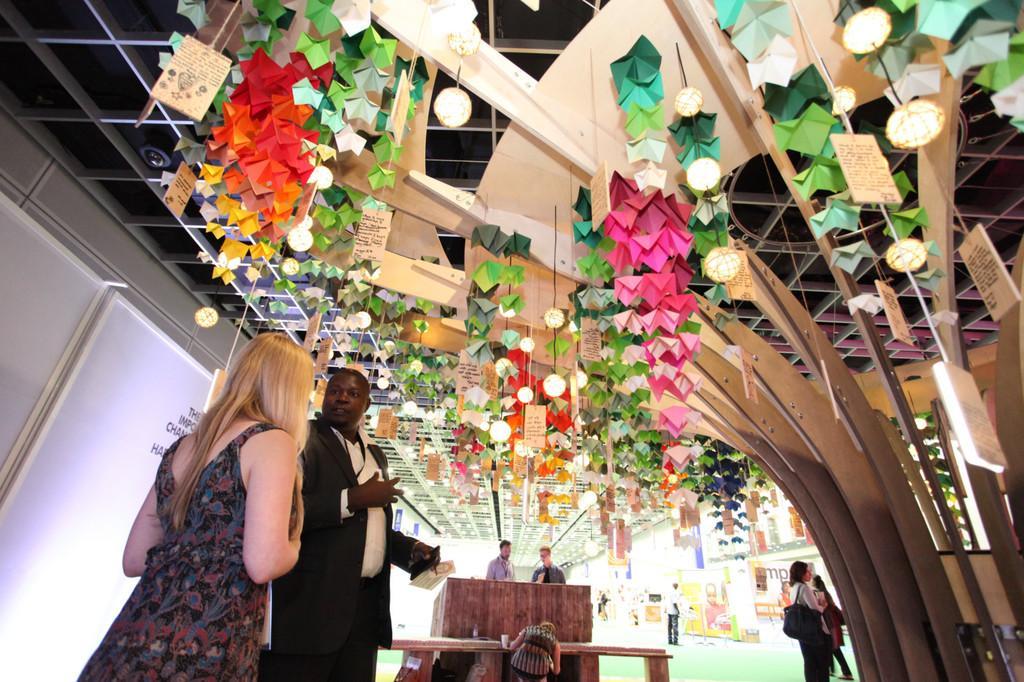How would you summarize this image in a sentence or two? This picture describes about group of people, they are standing, in front of them we can find lights and hoardings. 